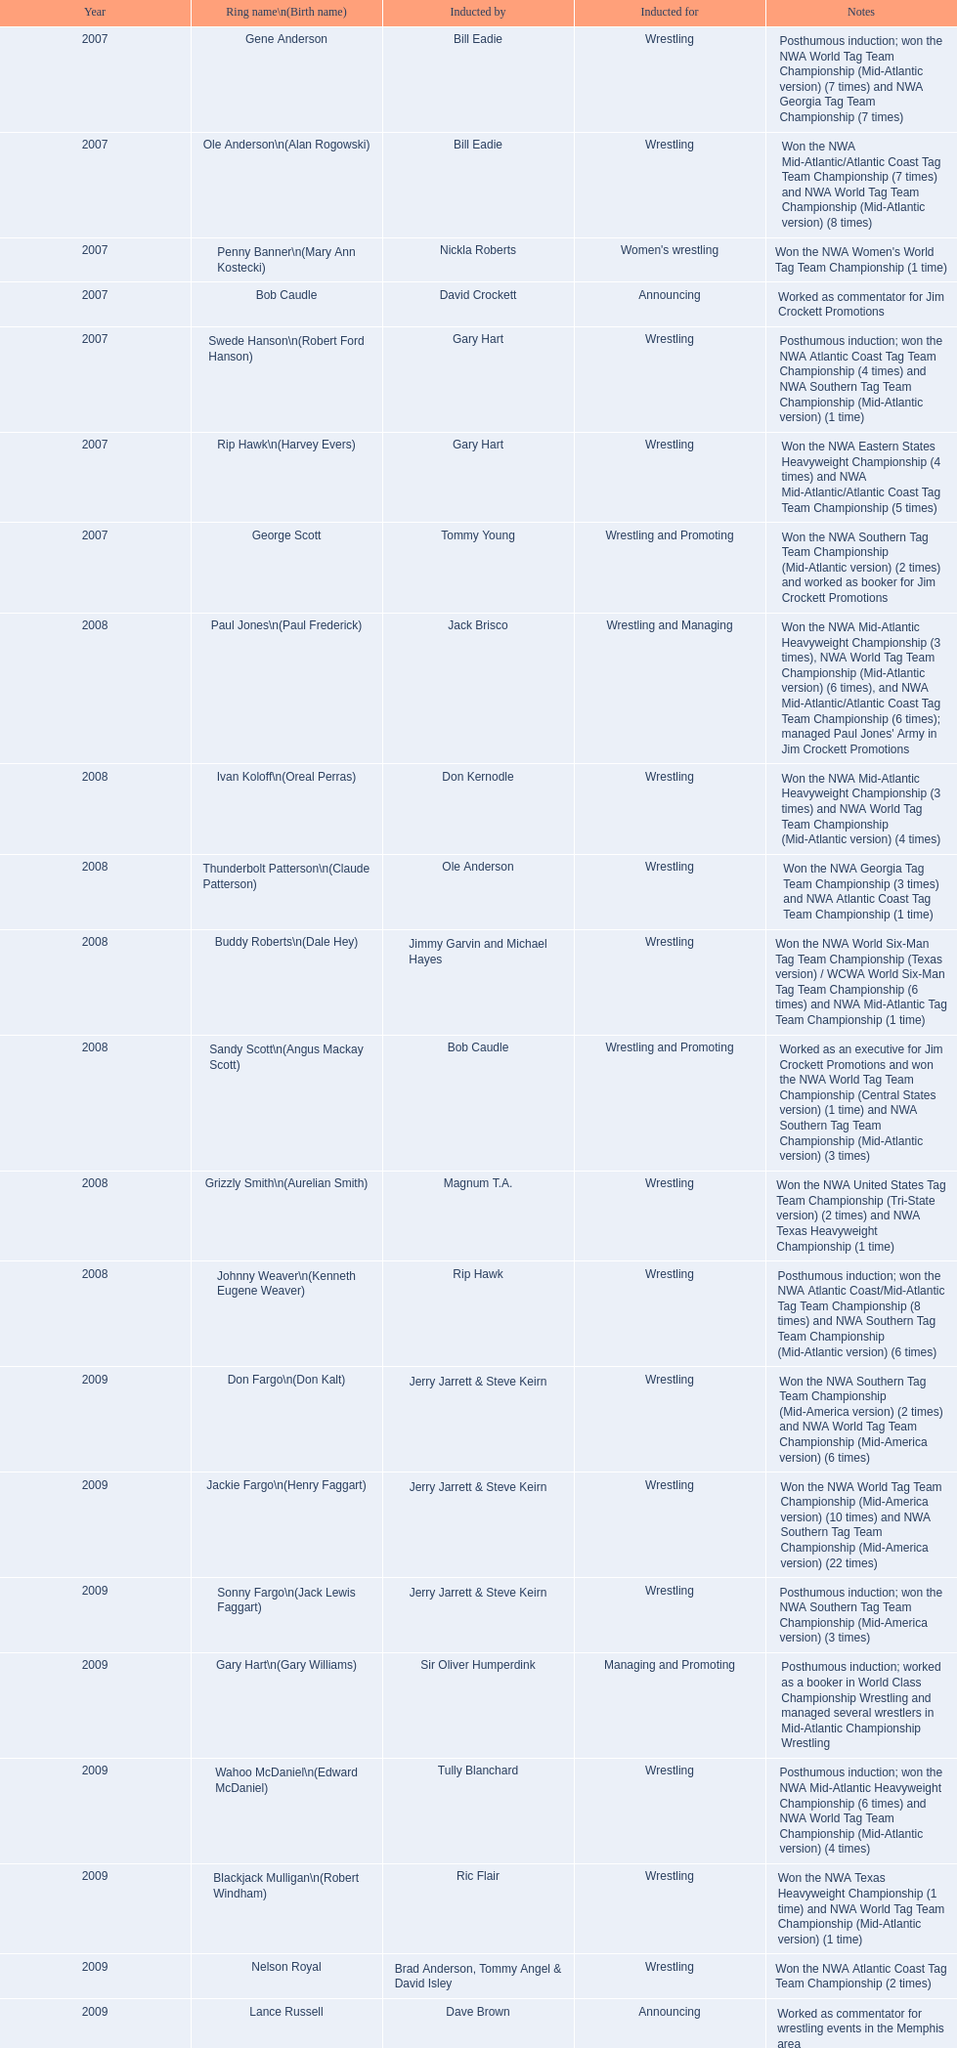In what year did the induction take place? 2007. Which inductee was deceased? Gene Anderson. 